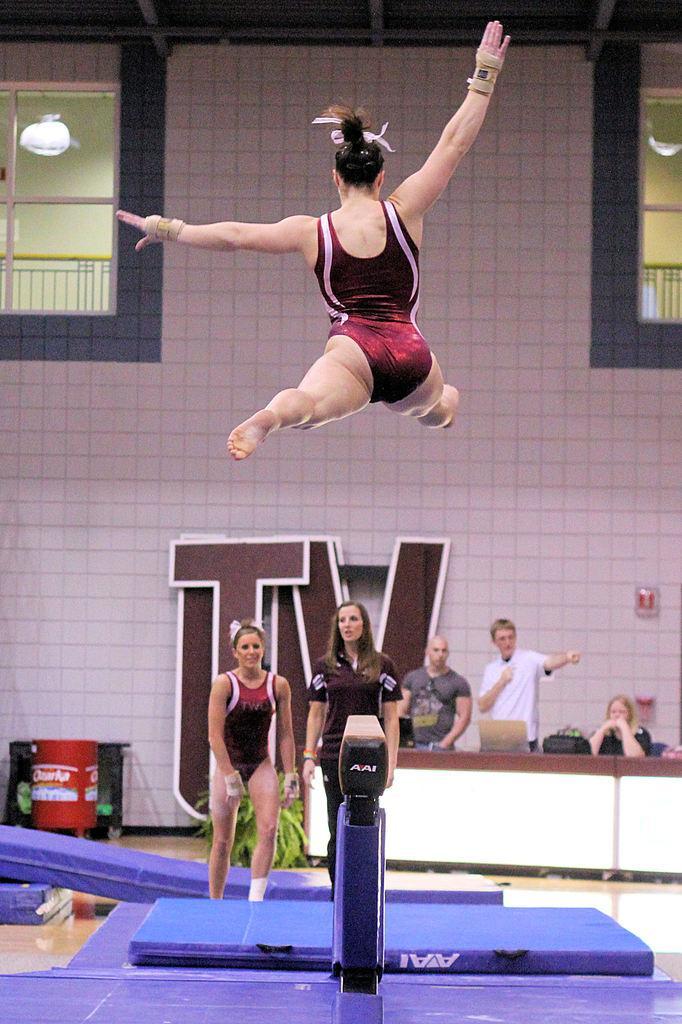How would you summarize this image in a sentence or two? In the center of the image we can see one pole and one person is jumping. In the background there is a wall, windows, fences, lights, one bed, one blue color object, one table, banners, few people are standing and few other objects. On the table, we can see one laptop, machine etc. 